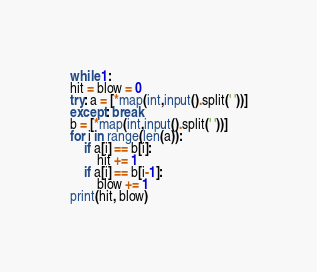Convert code to text. <code><loc_0><loc_0><loc_500><loc_500><_Python_>while 1:
hit = blow = 0
try: a = [*map(int,input().split(' '))]
except: break
b = [*map(int,input().split(' '))]
for i in range(len(a)):
	if a[i] == b[i]:
		hit += 1
	if a[i] == b[i-1]:
		blow += 1
print(hit, blow)
</code> 